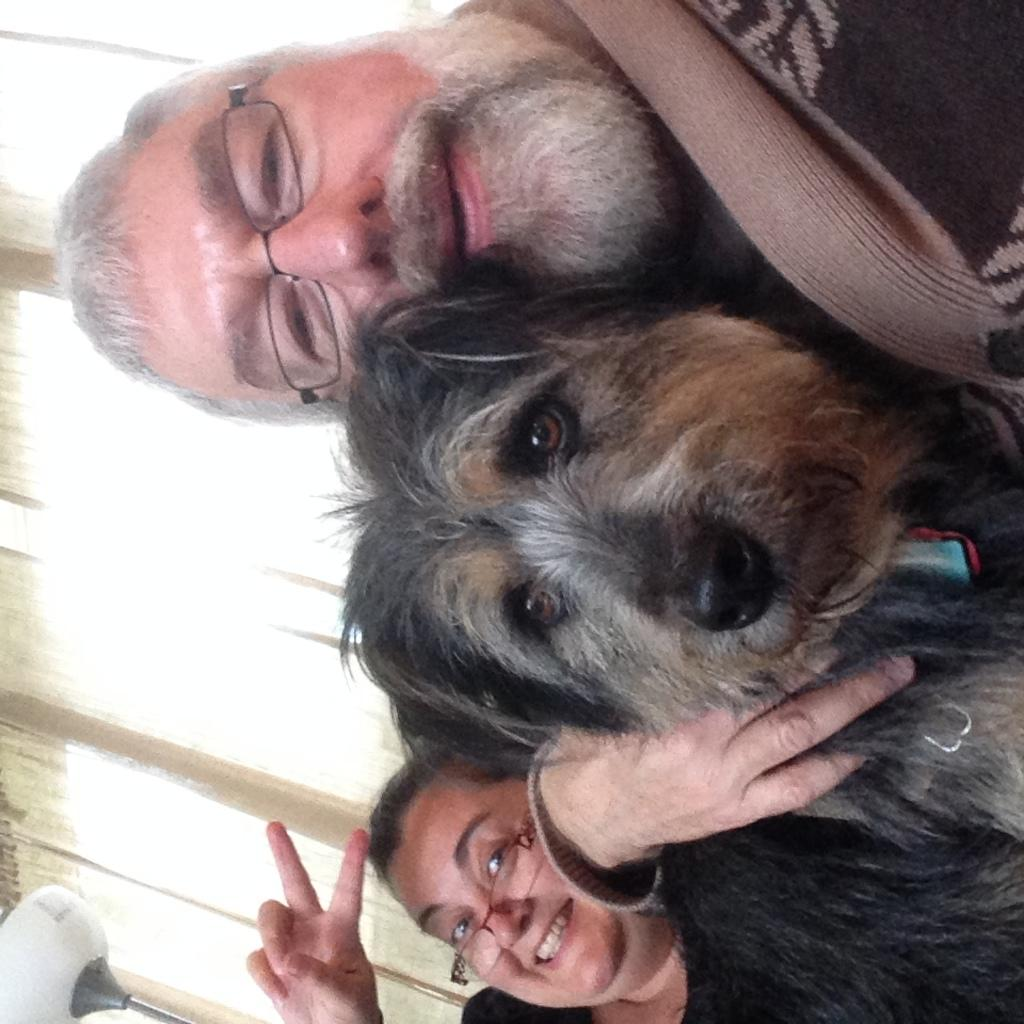How many people are in the image? There are two persons in the image. What is the facial expression of the persons in the image? The persons are smiling. What is the man holding in the image? The man is holding a dog in the image. What can be seen in the background of the image? There is a curtain in the background of the image. What type of prison can be seen in the image? There is no prison present in the image. 